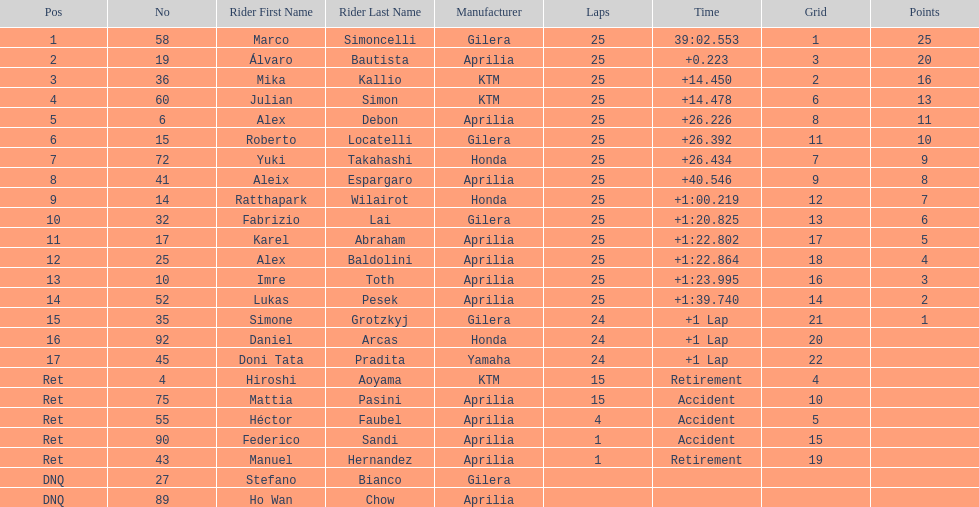Who perfomed the most number of laps, marco simoncelli or hiroshi aoyama? Marco Simoncelli. 